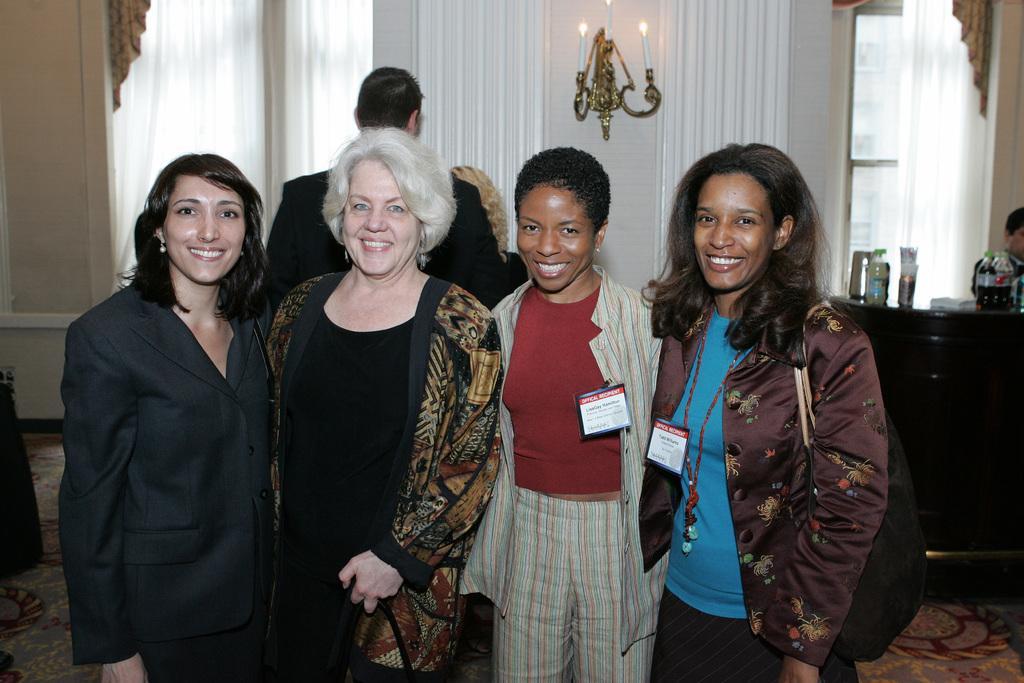Could you give a brief overview of what you see in this image? In this image, there are a few people. We can see a table with some objects like bottles. We can see the ground. We can also see the wall and some candles on an object. We can see a few curtains and some glass. We can also see some object on the left. 